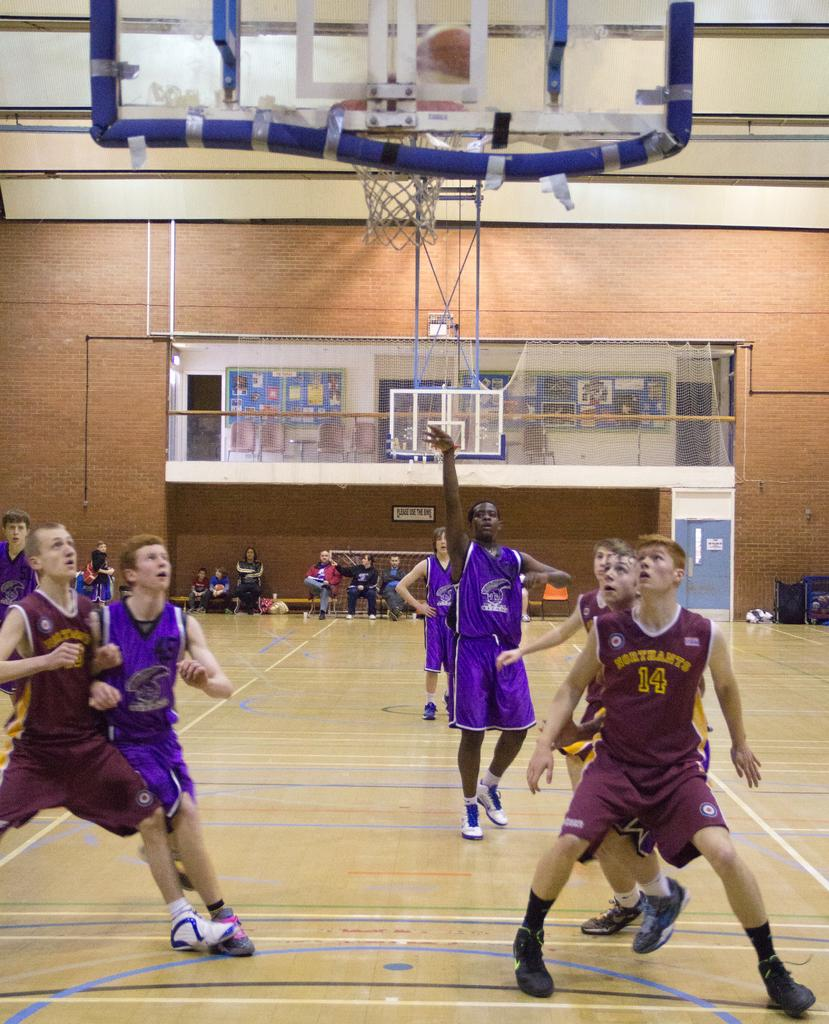<image>
Describe the image concisely. A basketball player no. 14 looks up from near the basket as another player shoots for the goal. 